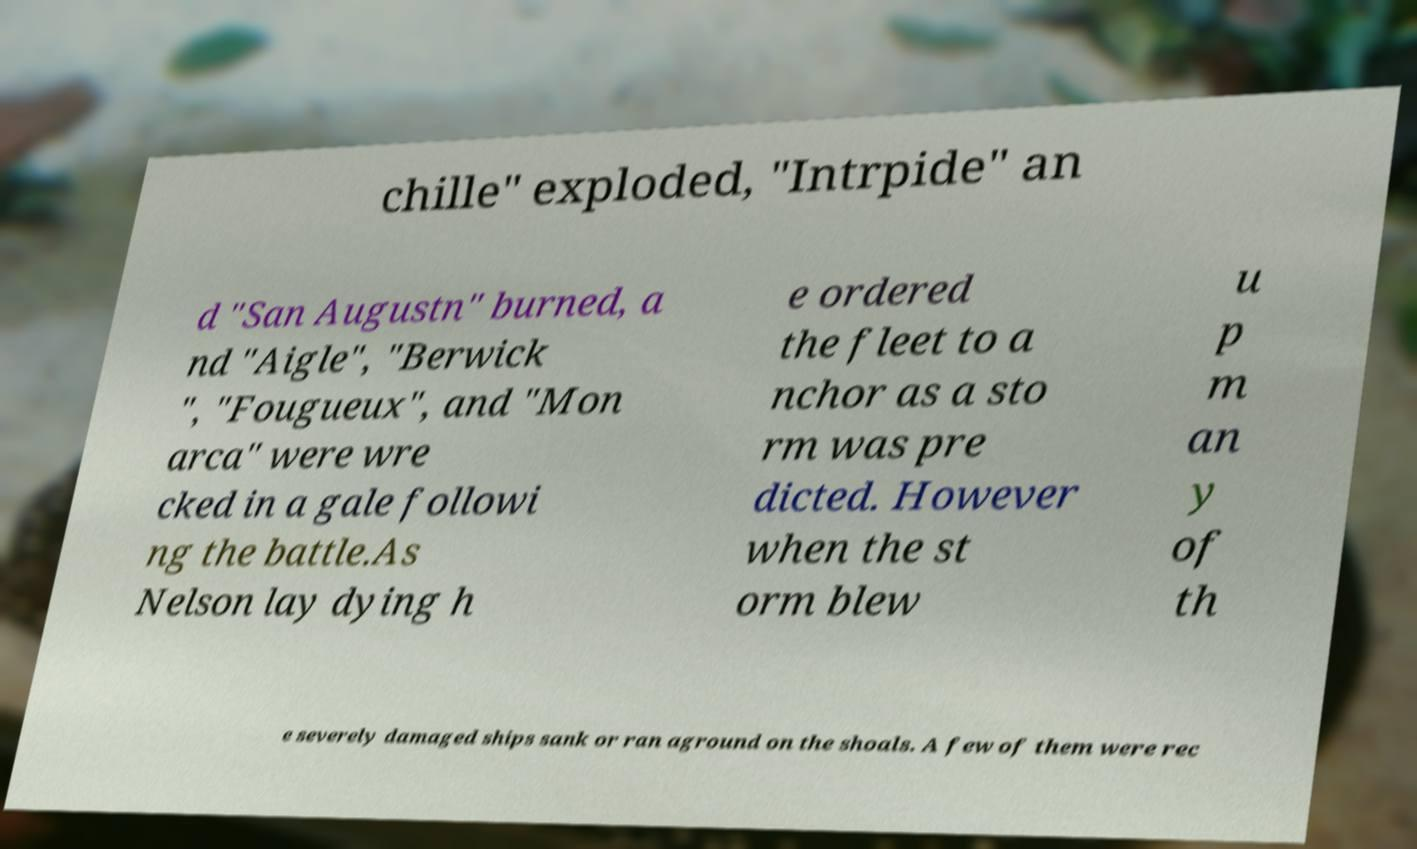Could you assist in decoding the text presented in this image and type it out clearly? chille" exploded, "Intrpide" an d "San Augustn" burned, a nd "Aigle", "Berwick ", "Fougueux", and "Mon arca" were wre cked in a gale followi ng the battle.As Nelson lay dying h e ordered the fleet to a nchor as a sto rm was pre dicted. However when the st orm blew u p m an y of th e severely damaged ships sank or ran aground on the shoals. A few of them were rec 